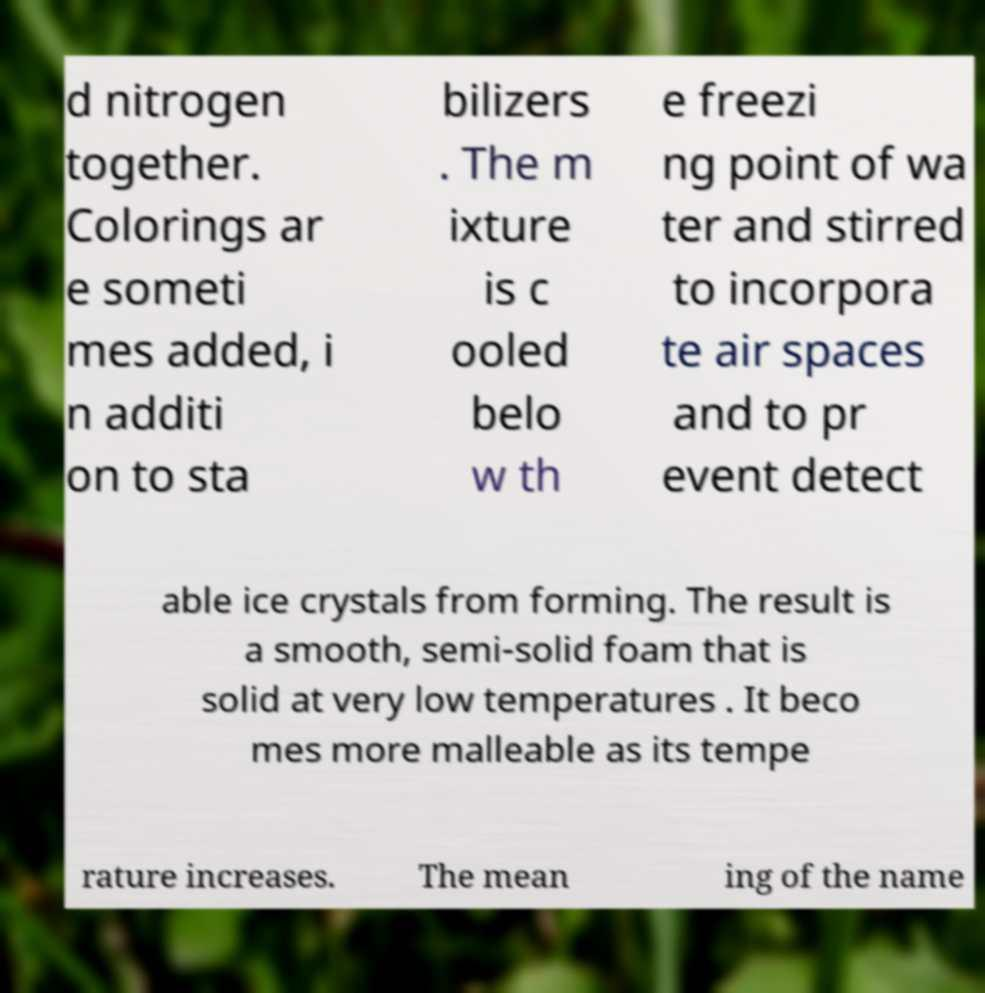There's text embedded in this image that I need extracted. Can you transcribe it verbatim? d nitrogen together. Colorings ar e someti mes added, i n additi on to sta bilizers . The m ixture is c ooled belo w th e freezi ng point of wa ter and stirred to incorpora te air spaces and to pr event detect able ice crystals from forming. The result is a smooth, semi-solid foam that is solid at very low temperatures . It beco mes more malleable as its tempe rature increases. The mean ing of the name 